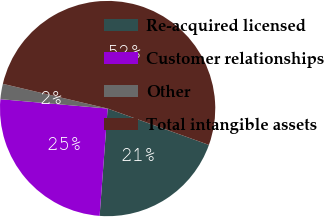<chart> <loc_0><loc_0><loc_500><loc_500><pie_chart><fcel>Re-acquired licensed<fcel>Customer relationships<fcel>Other<fcel>Total intangible assets<nl><fcel>20.7%<fcel>25.2%<fcel>2.3%<fcel>51.8%<nl></chart> 